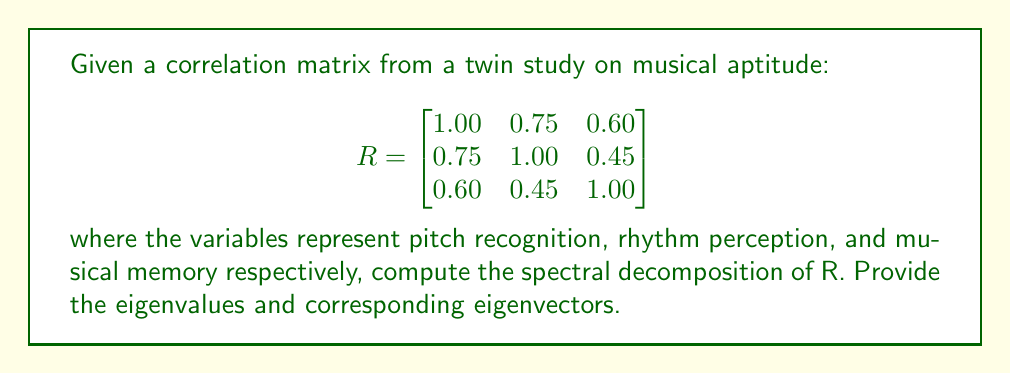Can you solve this math problem? To compute the spectral decomposition of the correlation matrix R, we need to find its eigenvalues and eigenvectors.

Step 1: Find the characteristic equation
$$\det(R - \lambda I) = 0$$

$$\begin{vmatrix}
1-\lambda & 0.75 & 0.60 \\
0.75 & 1-\lambda & 0.45 \\
0.60 & 0.45 & 1-\lambda
\end{vmatrix} = 0$$

Step 2: Expand the determinant
$$(1-\lambda)^3 - 0.75^2(1-\lambda) - 0.60^2(1-\lambda) - 0.45^2(1-\lambda) + 2(0.75)(0.60)(0.45) = 0$$

Step 3: Solve the characteristic equation
After simplification, we get:
$$-\lambda^3 + 3\lambda^2 - 1.6875\lambda + 0.2025 = 0$$

Using a numerical method or computer algebra system, we find the roots:
$$\lambda_1 \approx 2.2775, \lambda_2 \approx 0.5169, \lambda_3 \approx 0.2056$$

Step 4: Find the eigenvectors
For each eigenvalue $\lambda_i$, solve $(R - \lambda_i I)v_i = 0$

For $\lambda_1 \approx 2.2775$:
$$v_1 \approx [0.6124, 0.5653, 0.5524]^T$$

For $\lambda_2 \approx 0.5169$:
$$v_2 \approx [-0.3416, -0.4243, 0.8381]^T$$

For $\lambda_3 \approx 0.2056$:
$$v_3 \approx [0.7121, -0.7071, 0.0018]^T$$

Step 5: Normalize the eigenvectors
The eigenvectors above are already normalized.

Step 6: Write the spectral decomposition
$$R = V\Lambda V^T$$

where $V = [v_1 | v_2 | v_3]$ and $\Lambda = \text{diag}(\lambda_1, \lambda_2, \lambda_3)$
Answer: Eigenvalues: $\lambda_1 \approx 2.2775, \lambda_2 \approx 0.5169, \lambda_3 \approx 0.2056$
Eigenvectors: $v_1 \approx [0.6124, 0.5653, 0.5524]^T, v_2 \approx [-0.3416, -0.4243, 0.8381]^T, v_3 \approx [0.7121, -0.7071, 0.0018]^T$ 